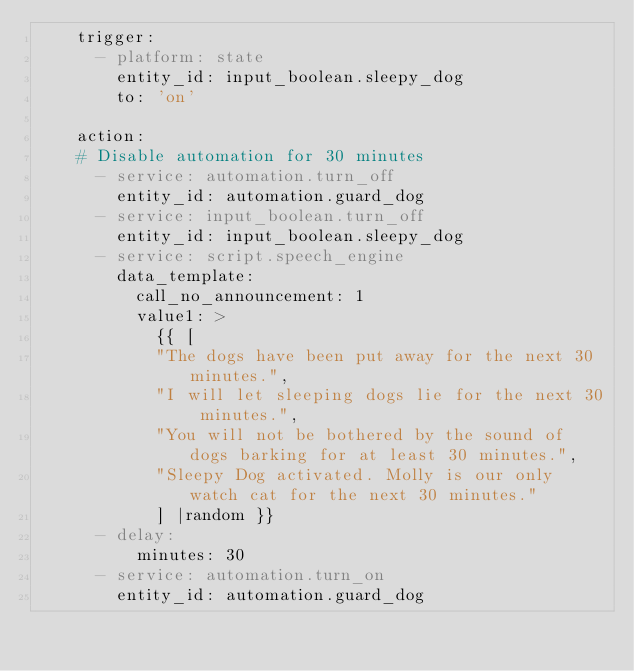Convert code to text. <code><loc_0><loc_0><loc_500><loc_500><_YAML_>    trigger:
      - platform: state
        entity_id: input_boolean.sleepy_dog
        to: 'on'

    action:
    # Disable automation for 30 minutes
      - service: automation.turn_off
        entity_id: automation.guard_dog
      - service: input_boolean.turn_off
        entity_id: input_boolean.sleepy_dog
      - service: script.speech_engine
        data_template:
          call_no_announcement: 1
          value1: >
            {{ [
            "The dogs have been put away for the next 30 minutes.",
            "I will let sleeping dogs lie for the next 30 minutes.",
            "You will not be bothered by the sound of dogs barking for at least 30 minutes.",
            "Sleepy Dog activated. Molly is our only watch cat for the next 30 minutes."
            ] |random }}
      - delay:
          minutes: 30
      - service: automation.turn_on
        entity_id: automation.guard_dog
</code> 